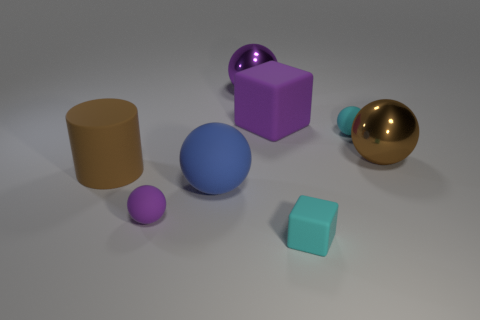Are there any big purple cubes on the right side of the cyan thing that is behind the brown thing to the left of the big purple metal object?
Your answer should be very brief. No. What number of purple rubber objects have the same size as the cyan cube?
Give a very brief answer. 1. There is a purple sphere in front of the blue ball; is its size the same as the blue sphere that is to the left of the large brown ball?
Provide a succinct answer. No. What shape is the rubber object that is both left of the tiny cyan ball and behind the big brown rubber object?
Your answer should be very brief. Cube. Are there any large matte balls of the same color as the tiny block?
Provide a short and direct response. No. Are any brown objects visible?
Provide a short and direct response. Yes. What color is the large metallic ball left of the purple block?
Your answer should be very brief. Purple. There is a cyan block; is it the same size as the rubber cube that is behind the cyan cube?
Your answer should be very brief. No. What is the size of the sphere that is both behind the brown metallic ball and in front of the large cube?
Offer a very short reply. Small. Are there any yellow cubes that have the same material as the blue thing?
Offer a terse response. No. 